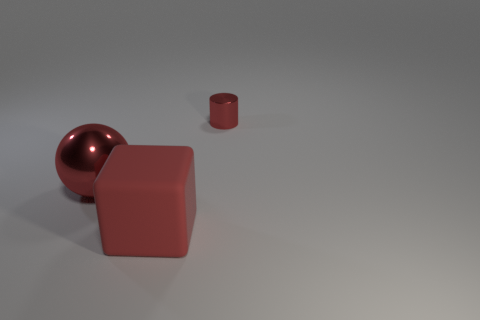Add 3 matte cubes. How many objects exist? 6 Subtract all cylinders. How many objects are left? 2 Add 2 large red matte blocks. How many large red matte blocks exist? 3 Subtract 0 green blocks. How many objects are left? 3 Subtract all cylinders. Subtract all rubber objects. How many objects are left? 1 Add 1 red cylinders. How many red cylinders are left? 2 